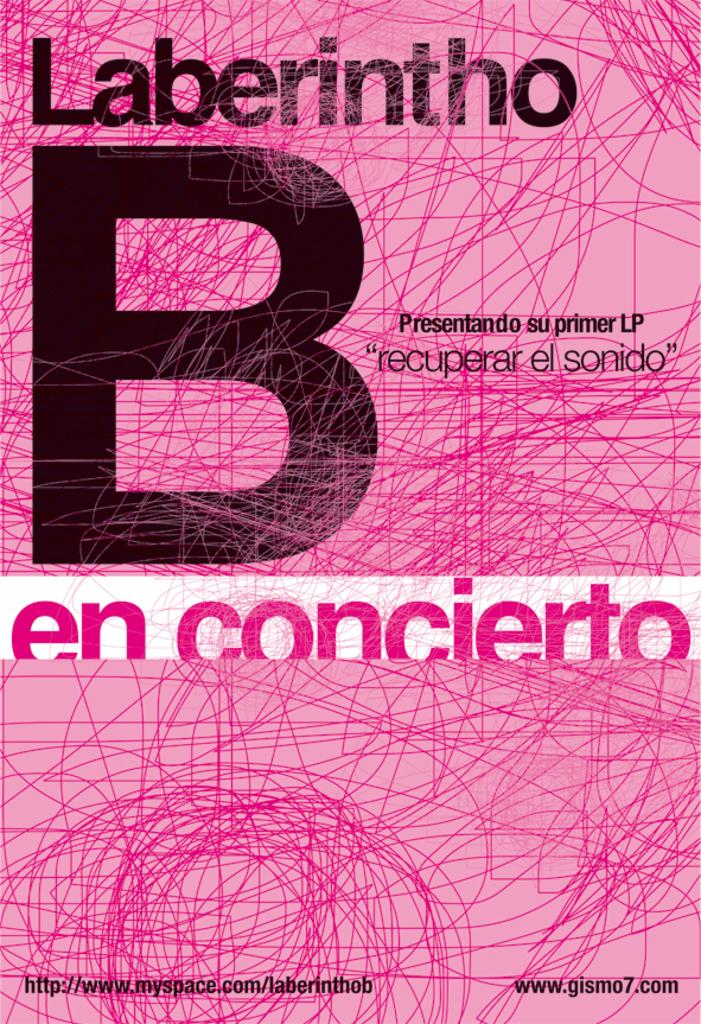<image>
Give a short and clear explanation of the subsequent image. a book cover of b en concierto by laberintho 